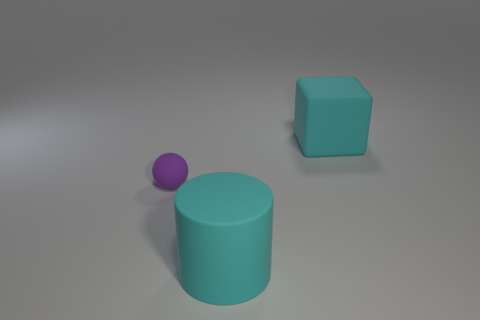Are there any other things that have the same size as the purple rubber thing?
Keep it short and to the point. No. Is the number of large blocks greater than the number of big things?
Give a very brief answer. No. What size is the object that is both behind the large rubber cylinder and in front of the big cyan rubber cube?
Give a very brief answer. Small. The purple matte thing has what shape?
Your answer should be compact. Sphere. How many other purple objects have the same shape as the small purple object?
Offer a very short reply. 0. Are there fewer large cyan rubber things that are on the left side of the big cyan cylinder than matte things behind the small matte sphere?
Offer a very short reply. Yes. What number of matte cylinders are in front of the big cyan rubber object that is behind the tiny purple rubber thing?
Your answer should be compact. 1. Are any big red matte objects visible?
Offer a very short reply. No. Is there a cyan object that has the same material as the ball?
Give a very brief answer. Yes. Is the number of cyan rubber blocks behind the small ball greater than the number of cylinders that are behind the cyan matte cylinder?
Ensure brevity in your answer.  Yes. 